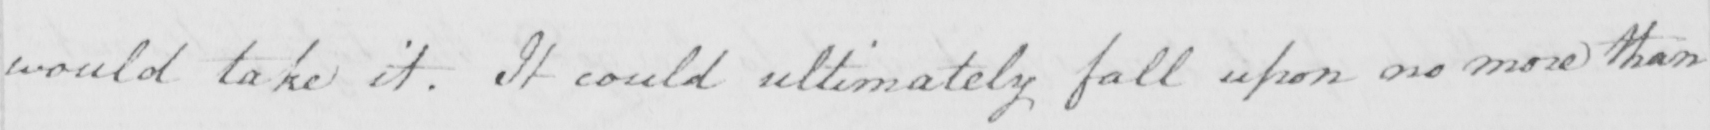What is written in this line of handwriting? would take it . It could ultimately fall upon no more than 